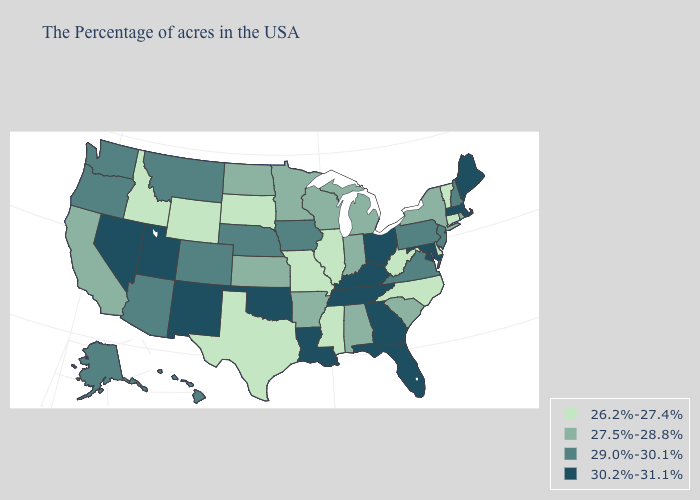What is the value of Connecticut?
Keep it brief. 26.2%-27.4%. Name the states that have a value in the range 27.5%-28.8%?
Keep it brief. Rhode Island, New York, South Carolina, Michigan, Indiana, Alabama, Wisconsin, Arkansas, Minnesota, Kansas, North Dakota, California. Name the states that have a value in the range 30.2%-31.1%?
Keep it brief. Maine, Massachusetts, Maryland, Ohio, Florida, Georgia, Kentucky, Tennessee, Louisiana, Oklahoma, New Mexico, Utah, Nevada. What is the lowest value in the West?
Write a very short answer. 26.2%-27.4%. Name the states that have a value in the range 30.2%-31.1%?
Quick response, please. Maine, Massachusetts, Maryland, Ohio, Florida, Georgia, Kentucky, Tennessee, Louisiana, Oklahoma, New Mexico, Utah, Nevada. What is the value of Nevada?
Keep it brief. 30.2%-31.1%. Does the map have missing data?
Write a very short answer. No. Among the states that border Louisiana , does Texas have the lowest value?
Answer briefly. Yes. Does Connecticut have the lowest value in the USA?
Keep it brief. Yes. Among the states that border Wyoming , which have the lowest value?
Short answer required. South Dakota, Idaho. Among the states that border Delaware , does New Jersey have the lowest value?
Short answer required. Yes. Does Florida have the same value as Iowa?
Answer briefly. No. Does Alaska have the same value as Oklahoma?
Concise answer only. No. What is the value of Indiana?
Quick response, please. 27.5%-28.8%. How many symbols are there in the legend?
Quick response, please. 4. 